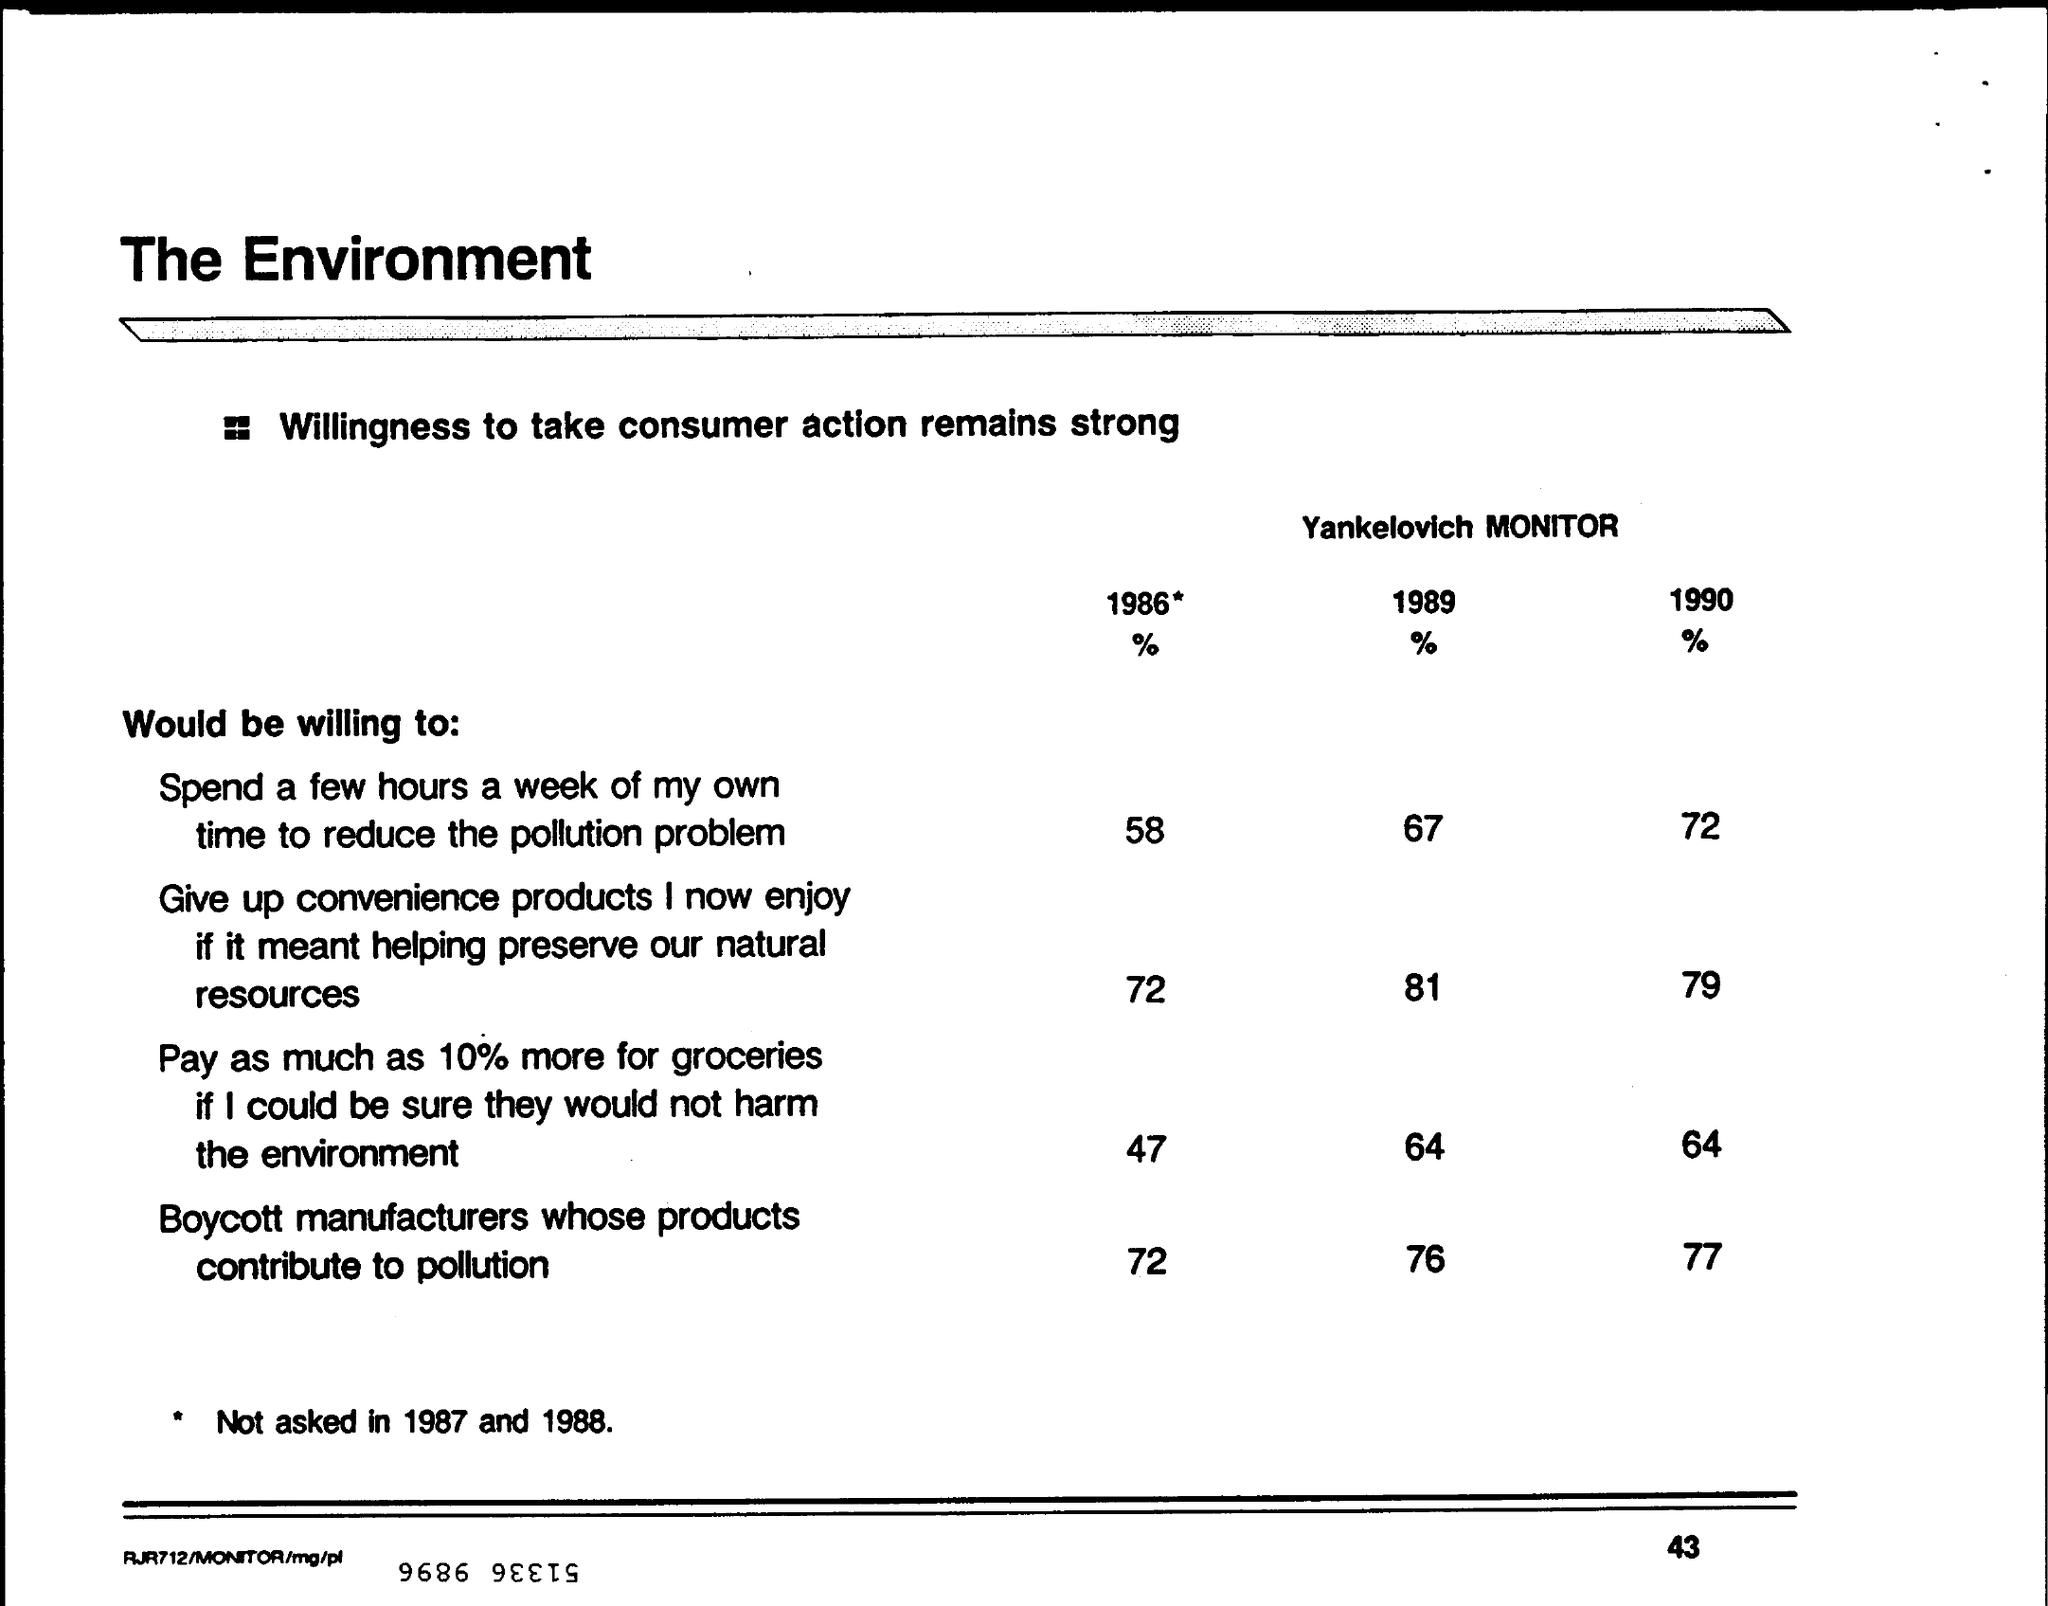What is the % of consumer would be willing to spend a few hours a week of my own time to reduce the pollution problem in the year 1990 ?
Provide a succinct answer. 72. What is the % of consumer would be willing to spend a few hours a week of my own time to reduce the pollution problem in the year 1989 ?
Your answer should be compact. 67. What is the % of boycott manufacturers whose products contribute to pollution in the year 1990?
Offer a very short reply. 77%. What is the % of boycott manufacturers whose products contribute to pollution in the year 1989?
Provide a succinct answer. 76%. 